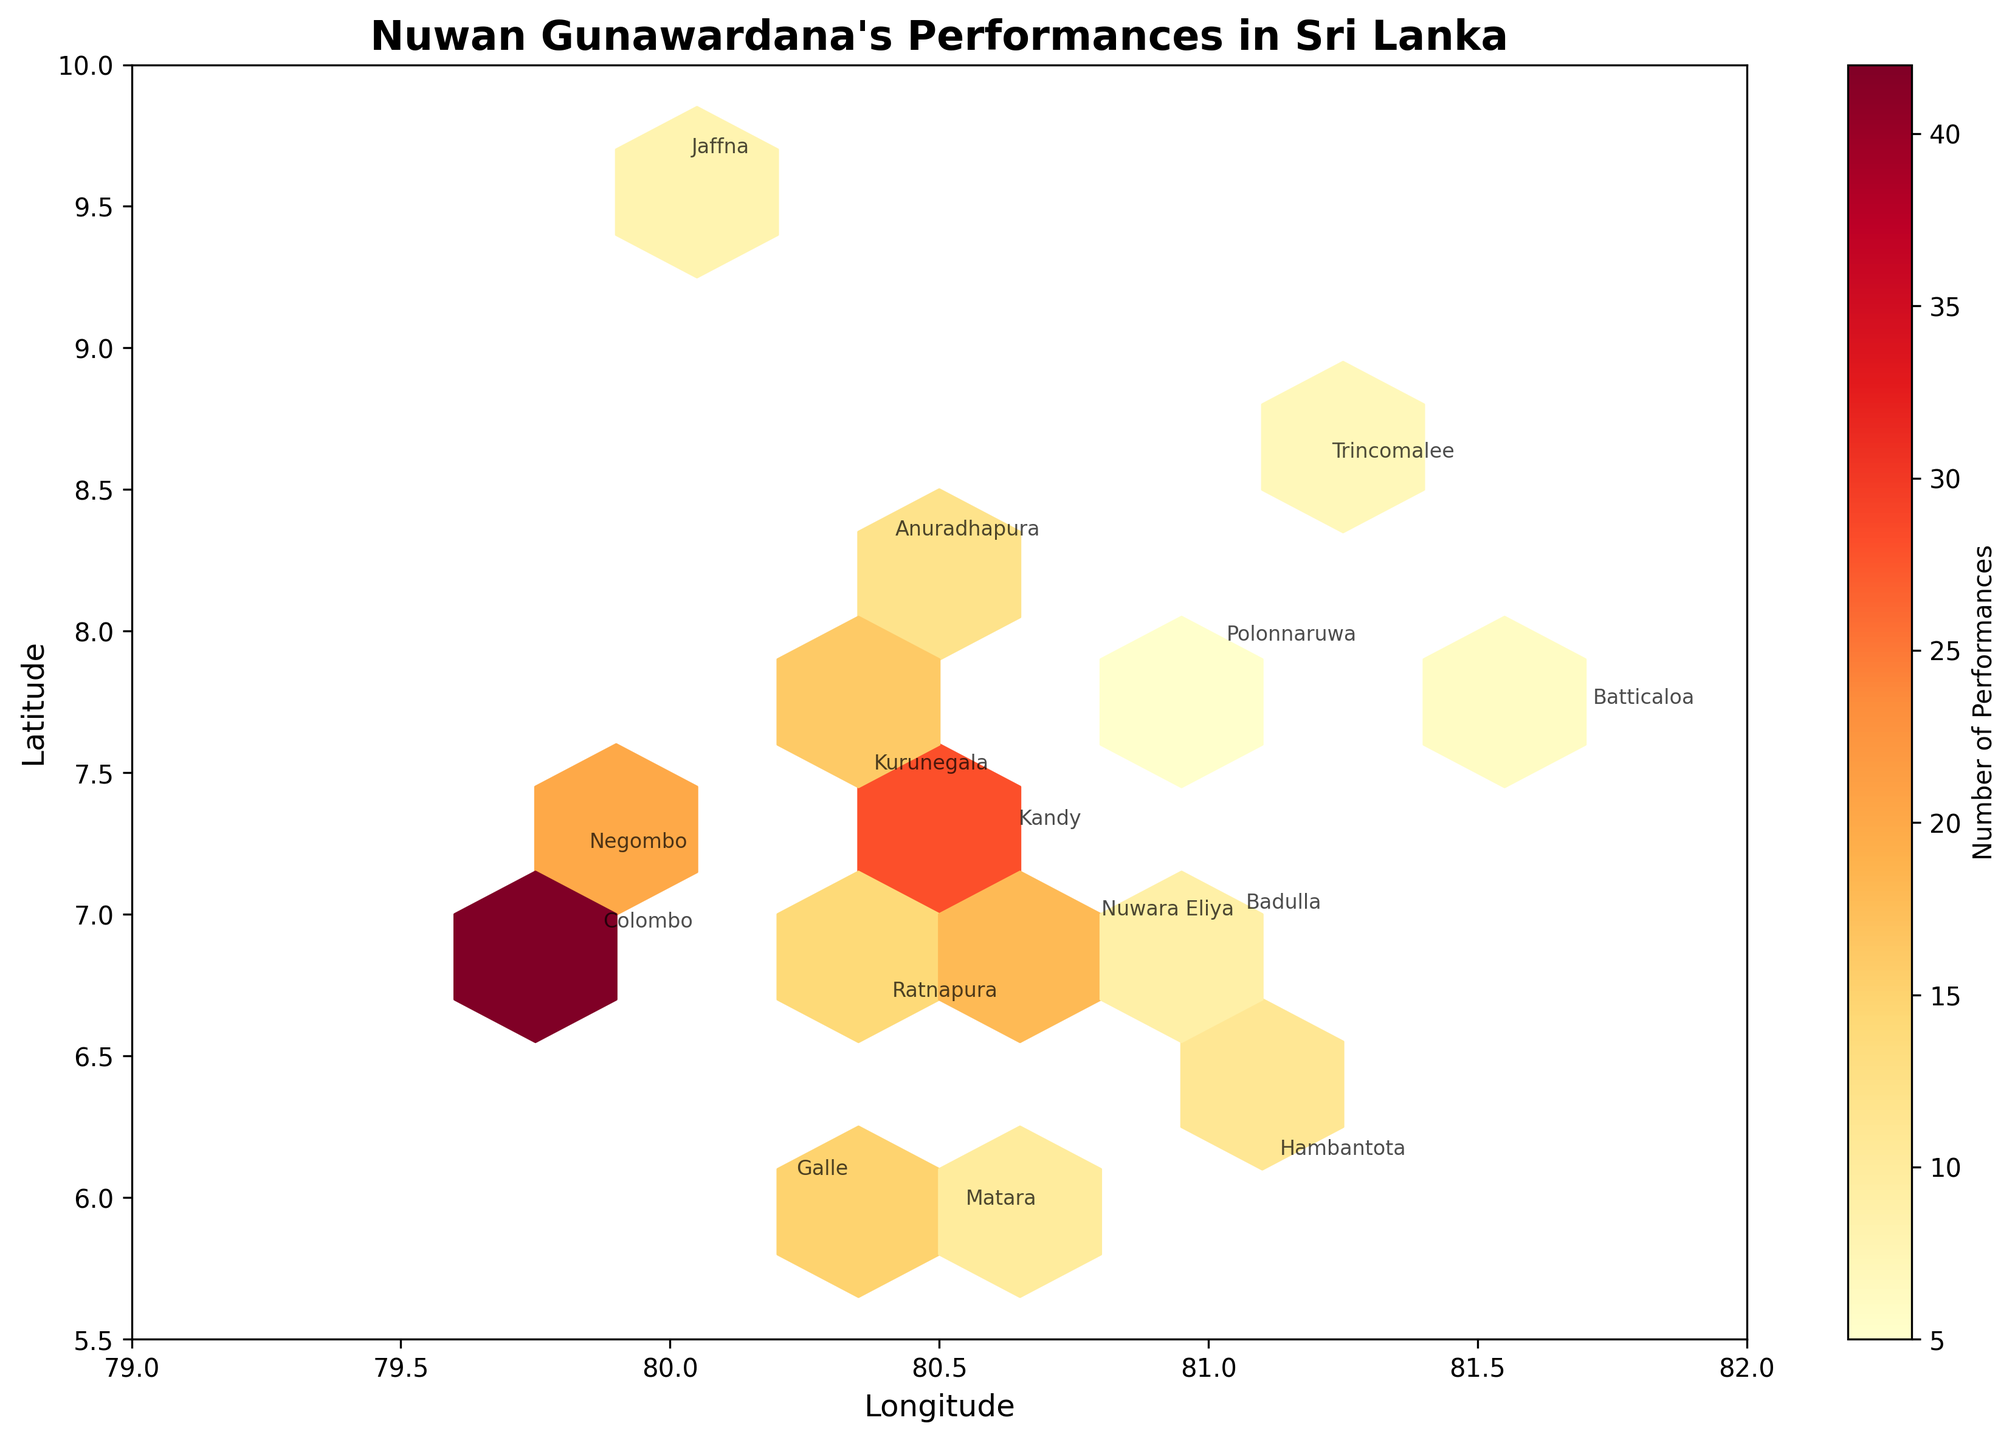What is the title of the hexbin plot? The title of the plot is displayed at the top of the figure. By looking at it, we can see what the focus of the figure is.
Answer: Nuwan Gunawardana's Performances in Sri Lanka What does the colorbar represent in the hexbin plot? The colorbar is labeled and shows the gradient of colors used in the plot. It indicates the quantity that each color represents.
Answer: Number of Performances Which region has the highest number of performances? Each region is annotated on the plot, and the color intensity on the hexbin indicates the number of performances. The region with the highest intensity/color on the plot corresponds to the highest number of performances.
Answer: Colombo Which region is located at the highest latitude? Looking at the y-axis (latitude), the highest latitude corresponds to the uppermost point on the plot. We can then refer to the annotation for the region located at this point.
Answer: Jaffna What is the relationship between the latitude and the number of performances across regions? By examining the spread of hexagons along the y-axis (latitude) and their corresponding color intensity, we can infer whether there's an observable trend linking latitude to the number of performances.
Answer: No clear relationship Which regions have fewer than 10 performances? By checking the annotations on the plot and the color intensity associated with the lower end of the colorbar, we can list the regions with a color indicating fewer than 10 performances.
Answer: Jaffna, Batticaloa, Trincomalee, Polonnaruwa Comparing Kandy and Negombo, which one has more performances? Referring to the annotations and the color intensity of the hexagons associated with these two regions, we can determine which region has a higher number of performances.
Answer: Kandy What are the possible reasons behind the clustering of performances in certain regions like Colombo? One needs to examine the geographic and demographic factors that aren't directly shown in the plot but can be inferred, such as population density, economic activity, and cultural significance of Colombo.
Answer: Higher population density, economic activity, cultural significance Approximately how many more performances does Colombo have compared to Kurunegala? By checking the number of performances annotated on the plot for both regions and calculating the difference, we can find how much more frequent performances are in Colombo.
Answer: 26 more performances What is the average number of performances across all regions? Sum the total number of performances from each region and divide by the number of regions (15). Sum: 42+28+15+8+12+20+6+18+10+7+14+9+16+11+5 = 221; Average = 221/15
Answer: 14.73 